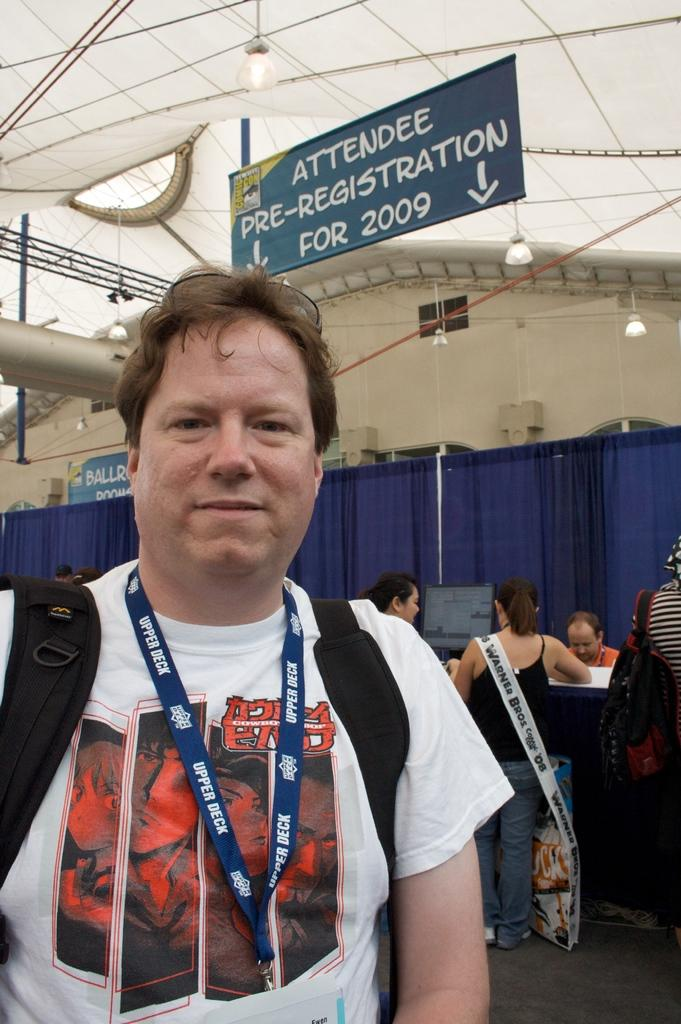Provide a one-sentence caption for the provided image. Man standing near the attendee pre-registration booth in 2009. 